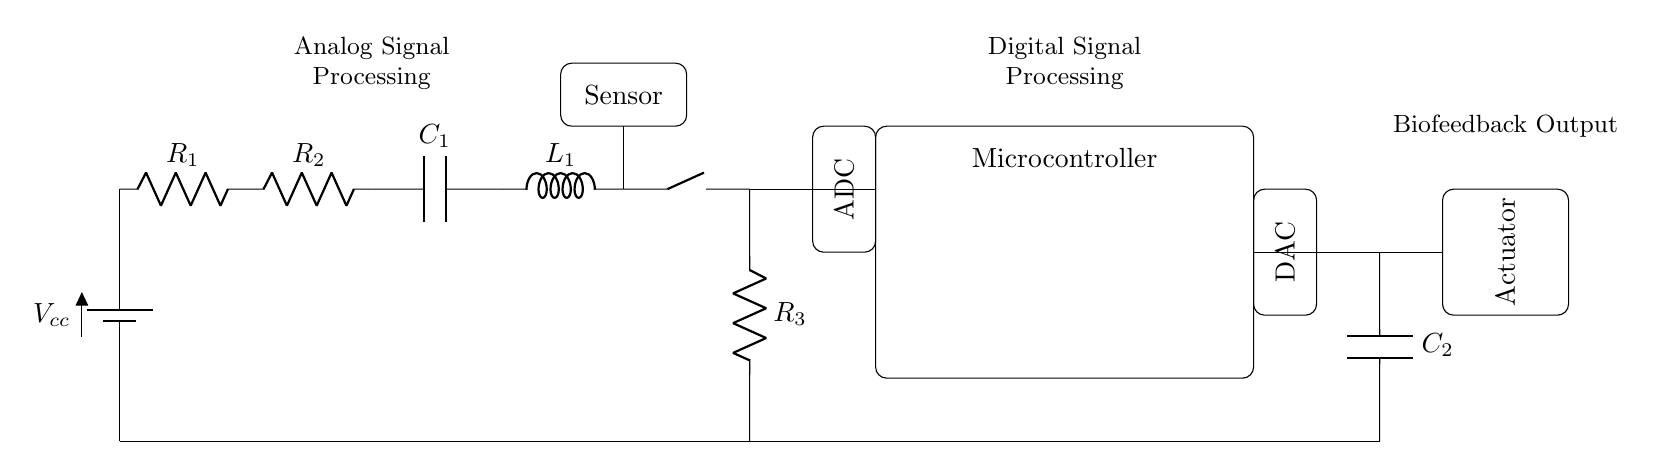What components are present in the analog section? The analog section includes a battery, resistors, a capacitor, an inductor, and a sensor. These components are essential for signal processing in biofeedback applications.
Answer: battery, resistors, capacitor, inductor, sensor What is the purpose of the ADC in this circuit? The Analog-to-Digital Converter (ADC) transforms analog signals from the sensor into digital signals that the microcontroller can interpret for further processing. This is critical in enabling digital control of the biofeedback device.
Answer: digital signal processing How many resistors are there in the circuit? By counting the components in the analog section, there are three distinct resistors labeled R1, R2, and R3. These resistors play a role in defining the circuit’s impedance and voltage distribution.
Answer: three What function does the actuator serve in this biofeedback device? The actuator is responsible for implementing the feedback received from the microcontroller, usually by creating a physical response based on the processed signals. This allows for interactive relaxation exercises tailored to the user's response.
Answer: physical response What is the function of the microcontroller in this circuit? The microcontroller acts as the central processing unit that manages the entire operation, including reading data from the ADC, processing the data, and sending commands to the actuator through the DAC. This is crucial for efficient control system operation.
Answer: central processing unit What type of signal does C2 handle? Capacitor C2 handles the filtering of digital signals after they are converted from analog to digital and vice versa, ensuring smooth transitions and stable output for the actuator. This contributes to the reliability of the biofeedback responses.
Answer: filtering digital signals What type of circuit is this: analog, digital, or hybrid? This circuit is classified as a hybrid because it incorporates both analog signal processing (for reading sensor inputs) and digital processing (using the microcontroller and DAC). This combination enhances the functionality of the biofeedback device.
Answer: hybrid 